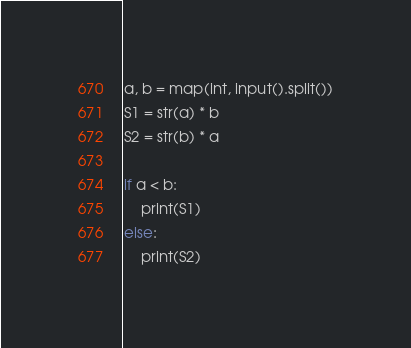<code> <loc_0><loc_0><loc_500><loc_500><_Python_>a, b = map(int, input().split())
S1 = str(a) * b
S2 = str(b) * a

if a < b:
    print(S1)
else:
    print(S2)</code> 